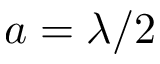<formula> <loc_0><loc_0><loc_500><loc_500>a = \lambda / 2</formula> 